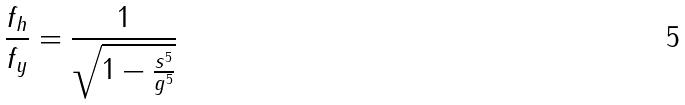<formula> <loc_0><loc_0><loc_500><loc_500>\frac { f _ { h } } { f _ { y } } = \frac { 1 } { \sqrt { 1 - \frac { s ^ { 5 } } { g ^ { 5 } } } }</formula> 